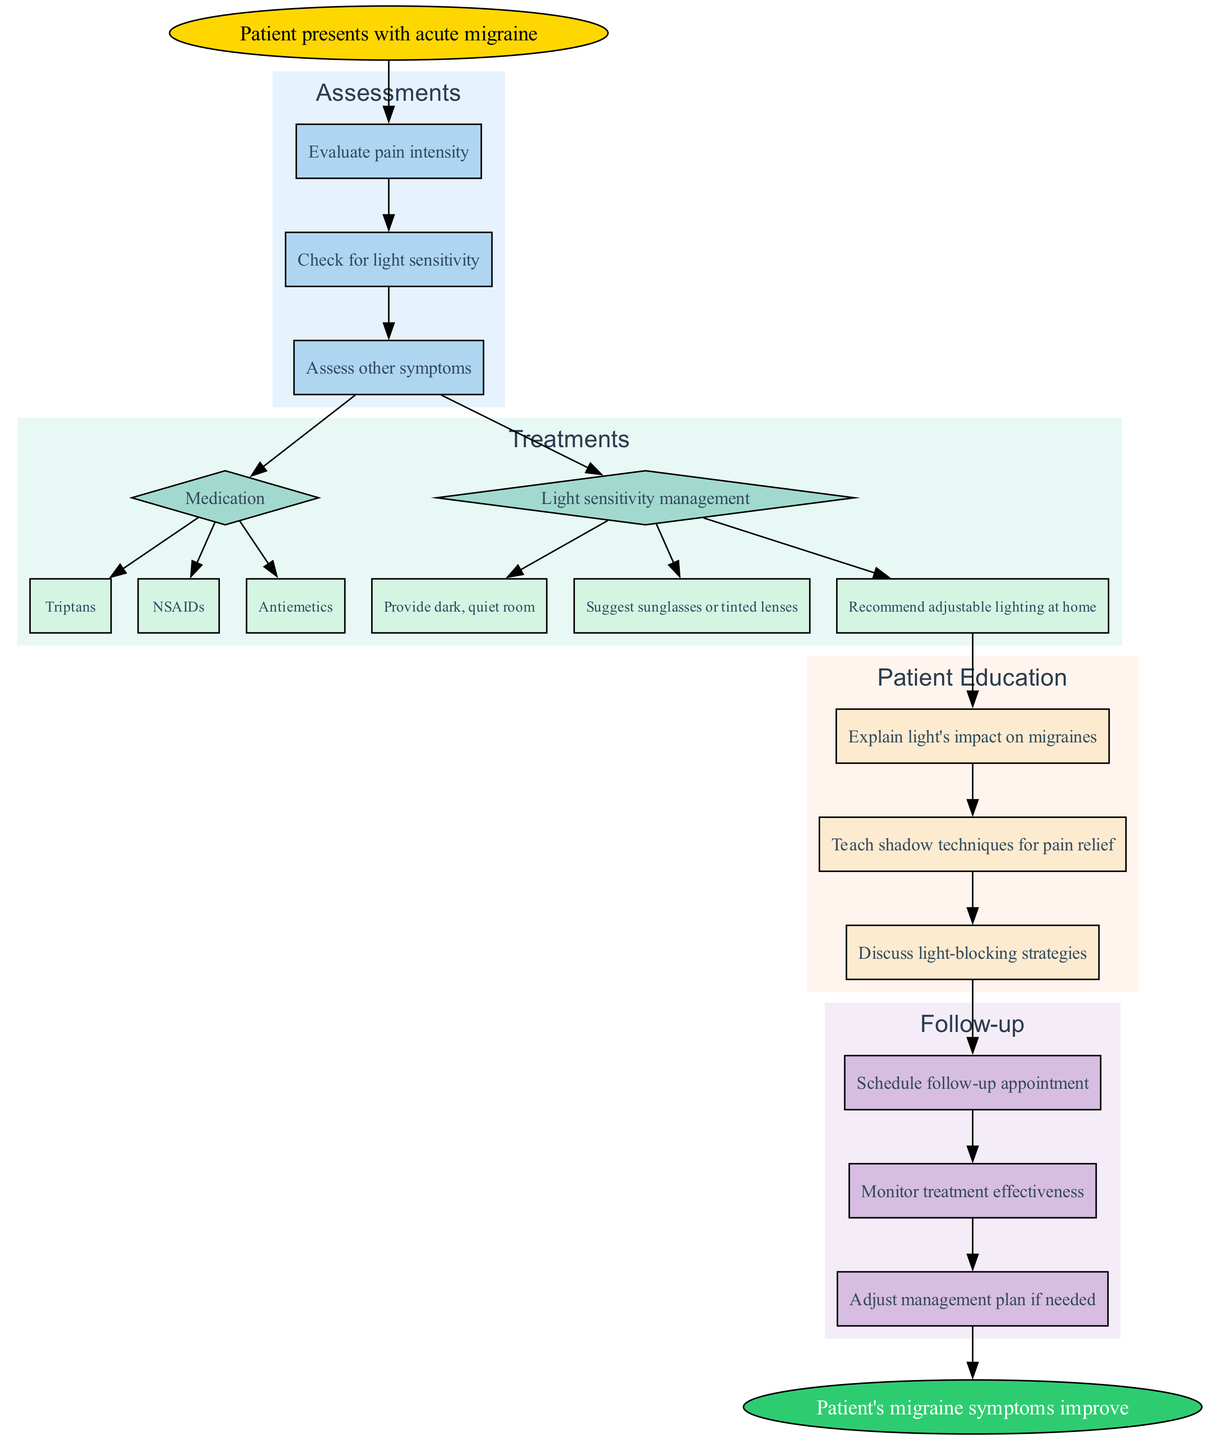What is the starting point of the clinical pathway? The diagram begins with the node titled "Patient presents with acute migraine," which indicates the point where the clinical pathway begins.
Answer: Patient presents with acute migraine How many assessments are included in the pathway? The diagram features three assessments: "Evaluate pain intensity," "Check for light sensitivity," and "Assess other symptoms," resulting in a total of three assessments.
Answer: 3 Which option is available for light sensitivity management? From the treatment category labeled "Light sensitivity management," one of the options listed is "Provide dark, quiet room," which specifically addresses light sensitivity.
Answer: Provide dark, quiet room What is the final step in the clinical pathway? The last node in the diagram is "Patient's migraine symptoms improve," which signifies the endpoint of the clinical pathway.
Answer: Patient's migraine symptoms improve How do treatments connect to assessments in the diagram? The treatments are connected to the last assessment "Assess other symptoms," indicating that this is the transitional step that leads to treatment options following the assessments.
Answer: Assess other symptoms What type of education is provided to patients regarding light? Among the patient education points, one plainly states "Explain light's impact on migraines," which directly relates to the management of light sensitivity in migraines.
Answer: Explain light's impact on migraines How many treatment options are there for medication? The "Medication" treatment category contains three options: "Triptans," "NSAIDs," and "Antiemetics," totaling three treatment options available for medication.
Answer: 3 Which two categories follow after the assessments? After the assessments, the diagram progresses to two categories: "Treatments" and "Patient Education," which are the next stages after evaluations have been conducted.
Answer: Treatments and Patient Education What does the diagram suggest for follow-up actions? The follow-up actions include "Schedule follow-up appointment," "Monitor treatment effectiveness," and "Adjust management plan if needed," outlining the steps for subsequent care after initial treatments.
Answer: Schedule follow-up appointment, Monitor treatment effectiveness, Adjust management plan if needed 